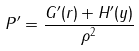Convert formula to latex. <formula><loc_0><loc_0><loc_500><loc_500>P ^ { \prime } = \frac { G ^ { \prime } ( r ) + H ^ { \prime } ( y ) } { \rho ^ { 2 } }</formula> 